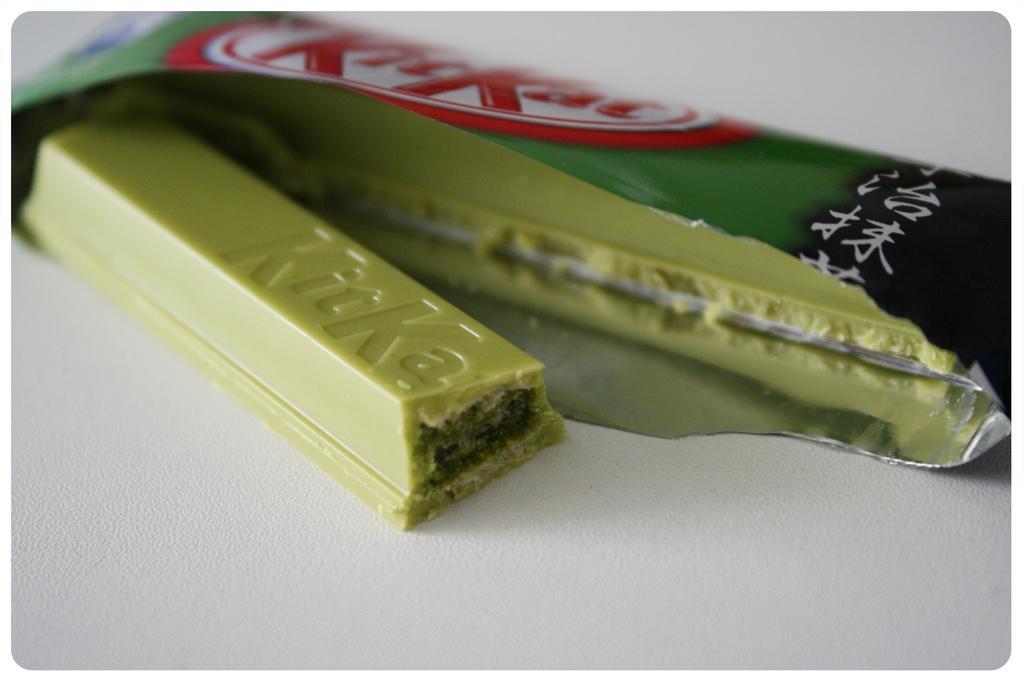How would you summarize this image in a sentence or two? In this image there is a kit kat chocolate on the table. 